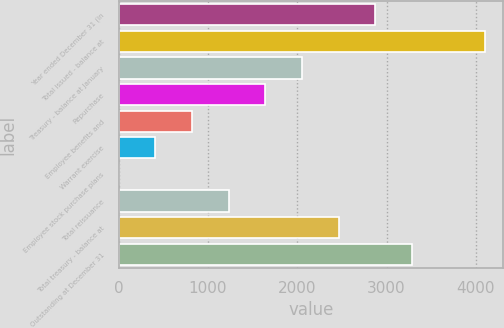Convert chart to OTSL. <chart><loc_0><loc_0><loc_500><loc_500><bar_chart><fcel>Year ended December 31 (in<fcel>Total issued - balance at<fcel>Treasury - balance at January<fcel>Repurchase<fcel>Employee benefits and<fcel>Warrant exercise<fcel>Employee stock purchase plans<fcel>Total reissuance<fcel>Total treasury - balance at<fcel>Outstanding at December 31<nl><fcel>2873.7<fcel>4104.9<fcel>2052.9<fcel>1642.5<fcel>821.7<fcel>411.3<fcel>0.9<fcel>1232.1<fcel>2463.3<fcel>3284.1<nl></chart> 